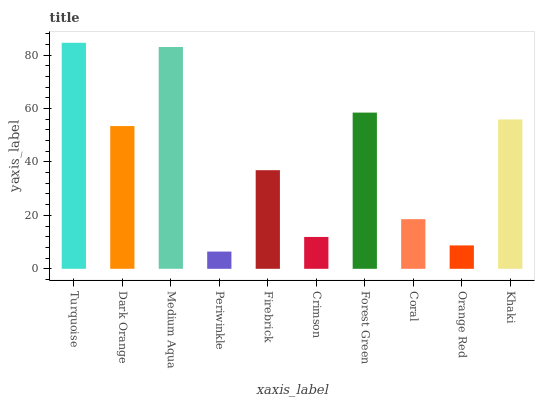Is Periwinkle the minimum?
Answer yes or no. Yes. Is Turquoise the maximum?
Answer yes or no. Yes. Is Dark Orange the minimum?
Answer yes or no. No. Is Dark Orange the maximum?
Answer yes or no. No. Is Turquoise greater than Dark Orange?
Answer yes or no. Yes. Is Dark Orange less than Turquoise?
Answer yes or no. Yes. Is Dark Orange greater than Turquoise?
Answer yes or no. No. Is Turquoise less than Dark Orange?
Answer yes or no. No. Is Dark Orange the high median?
Answer yes or no. Yes. Is Firebrick the low median?
Answer yes or no. Yes. Is Coral the high median?
Answer yes or no. No. Is Coral the low median?
Answer yes or no. No. 